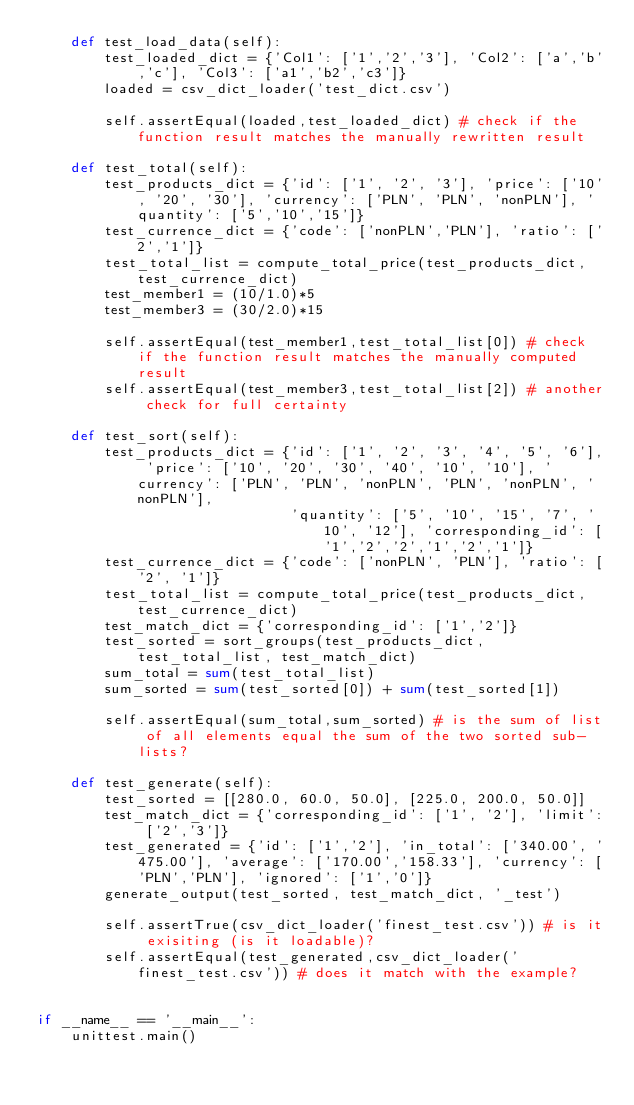Convert code to text. <code><loc_0><loc_0><loc_500><loc_500><_Python_>    def test_load_data(self):
        test_loaded_dict = {'Col1': ['1','2','3'], 'Col2': ['a','b','c'], 'Col3': ['a1','b2','c3']}
        loaded = csv_dict_loader('test_dict.csv')

        self.assertEqual(loaded,test_loaded_dict) # check if the function result matches the manually rewritten result

    def test_total(self):
        test_products_dict = {'id': ['1', '2', '3'], 'price': ['10', '20', '30'], 'currency': ['PLN', 'PLN', 'nonPLN'], 'quantity': ['5','10','15']}
        test_currence_dict = {'code': ['nonPLN','PLN'], 'ratio': ['2','1']}
        test_total_list = compute_total_price(test_products_dict,test_currence_dict)
        test_member1 = (10/1.0)*5
        test_member3 = (30/2.0)*15

        self.assertEqual(test_member1,test_total_list[0]) # check if the function result matches the manually computed result
        self.assertEqual(test_member3,test_total_list[2]) # another check for full certainty

    def test_sort(self):
        test_products_dict = {'id': ['1', '2', '3', '4', '5', '6'], 'price': ['10', '20', '30', '40', '10', '10'], 'currency': ['PLN', 'PLN', 'nonPLN', 'PLN', 'nonPLN', 'nonPLN'],
                              'quantity': ['5', '10', '15', '7', '10', '12'], 'corresponding_id': ['1','2','2','1','2','1']}
        test_currence_dict = {'code': ['nonPLN', 'PLN'], 'ratio': ['2', '1']}
        test_total_list = compute_total_price(test_products_dict,test_currence_dict)
        test_match_dict = {'corresponding_id': ['1','2']}
        test_sorted = sort_groups(test_products_dict, test_total_list, test_match_dict)
        sum_total = sum(test_total_list)
        sum_sorted = sum(test_sorted[0]) + sum(test_sorted[1])

        self.assertEqual(sum_total,sum_sorted) # is the sum of list of all elements equal the sum of the two sorted sub-lists?

    def test_generate(self):
        test_sorted = [[280.0, 60.0, 50.0], [225.0, 200.0, 50.0]]
        test_match_dict = {'corresponding_id': ['1', '2'], 'limit': ['2','3']}
        test_generated = {'id': ['1','2'], 'in_total': ['340.00', '475.00'], 'average': ['170.00','158.33'], 'currency': ['PLN','PLN'], 'ignored': ['1','0']}
        generate_output(test_sorted, test_match_dict, '_test')

        self.assertTrue(csv_dict_loader('finest_test.csv')) # is it exisiting (is it loadable)?
        self.assertEqual(test_generated,csv_dict_loader('finest_test.csv')) # does it match with the example?

        
if __name__ == '__main__':
    unittest.main()
</code> 